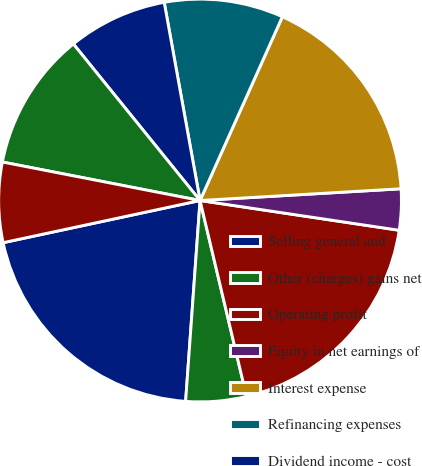Convert chart. <chart><loc_0><loc_0><loc_500><loc_500><pie_chart><fcel>Selling general and<fcel>Other (charges) gains net<fcel>Operating profit<fcel>Equity in net earnings of<fcel>Interest expense<fcel>Refinancing expenses<fcel>Dividend income - cost<fcel>Earnings from continuing<fcel>Earnings from discontinued<nl><fcel>20.5%<fcel>4.85%<fcel>18.93%<fcel>3.29%<fcel>17.37%<fcel>9.55%<fcel>7.98%<fcel>11.11%<fcel>6.42%<nl></chart> 